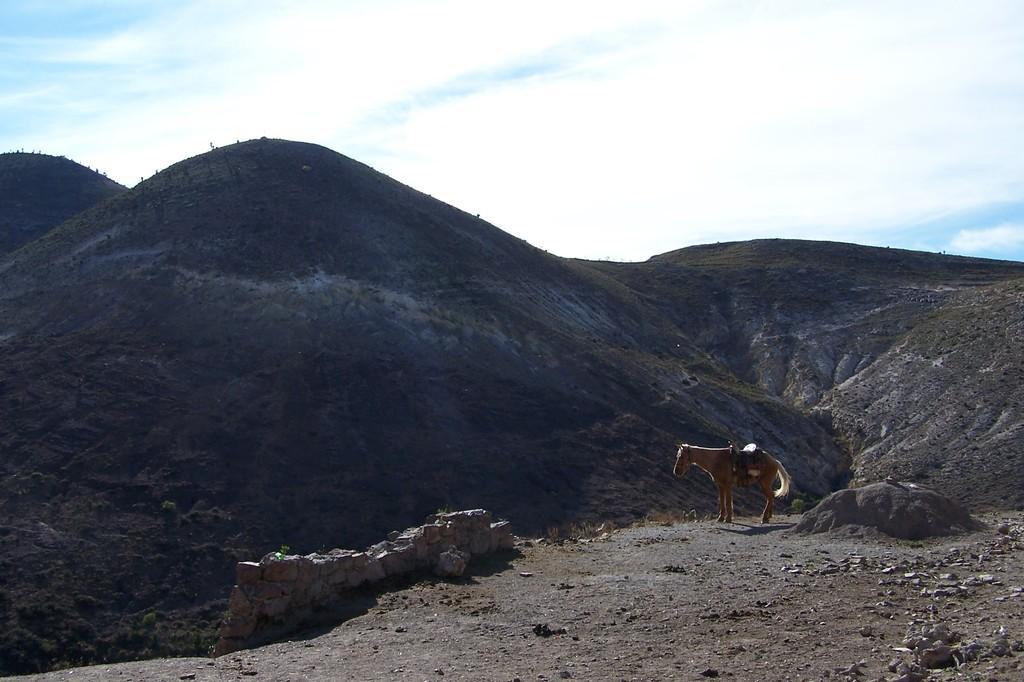How would you summarize this image in a sentence or two? In this image we can see a horse on the ground. We can also see some stones, the rocks, a group of trees on the hills and the sky which looks cloudy. 